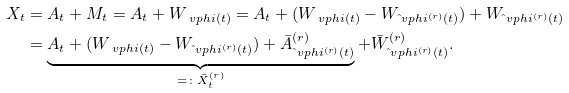Convert formula to latex. <formula><loc_0><loc_0><loc_500><loc_500>X _ { t } & = A _ { t } + M _ { t } = A _ { t } + W _ { \ v p h i ( t ) } = A _ { t } + ( W _ { \ v p h i ( t ) } - W _ { \hat { \ } v p h i ^ { ( r ) } ( t ) } ) + W _ { \hat { \ } v p h i ^ { ( r ) } ( t ) } \\ & = \underbrace { A _ { t } + ( W _ { \ v p h i ( t ) } - W _ { \hat { \ } v p h i ^ { ( r ) } ( t ) } ) + \bar { A } ^ { ( r ) } _ { \hat { \ } v p h i ^ { ( r ) } ( t ) } } _ { = \colon \bar { X } ^ { ( r ) } _ { t } } + \bar { W } ^ { ( r ) } _ { \hat { \ } v p h i ^ { ( r ) } ( t ) } .</formula> 